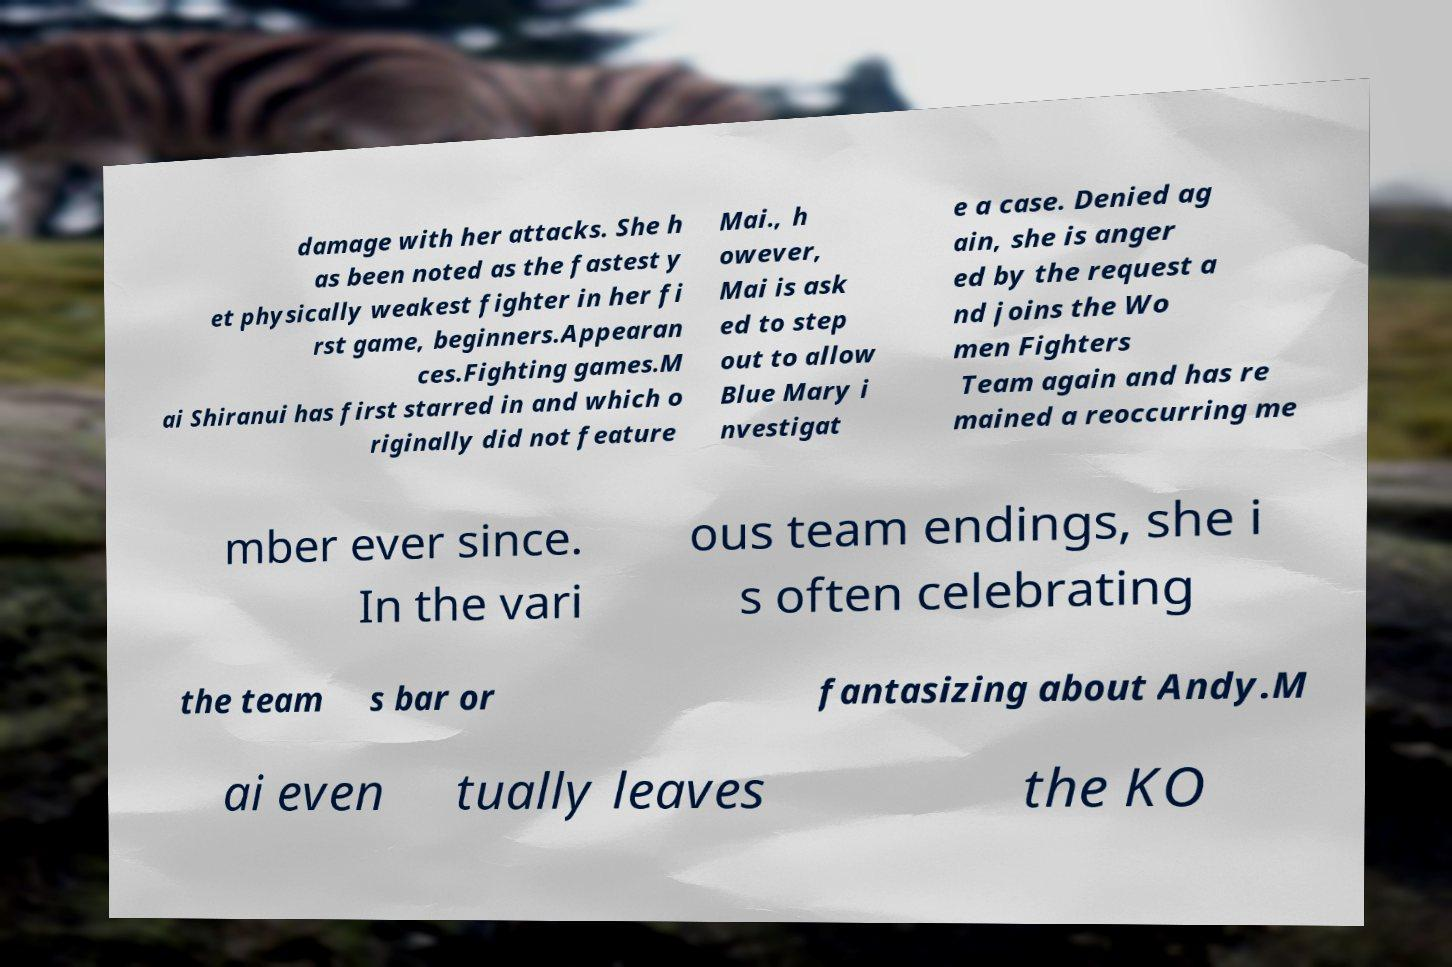Please identify and transcribe the text found in this image. damage with her attacks. She h as been noted as the fastest y et physically weakest fighter in her fi rst game, beginners.Appearan ces.Fighting games.M ai Shiranui has first starred in and which o riginally did not feature Mai., h owever, Mai is ask ed to step out to allow Blue Mary i nvestigat e a case. Denied ag ain, she is anger ed by the request a nd joins the Wo men Fighters Team again and has re mained a reoccurring me mber ever since. In the vari ous team endings, she i s often celebrating the team s bar or fantasizing about Andy.M ai even tually leaves the KO 